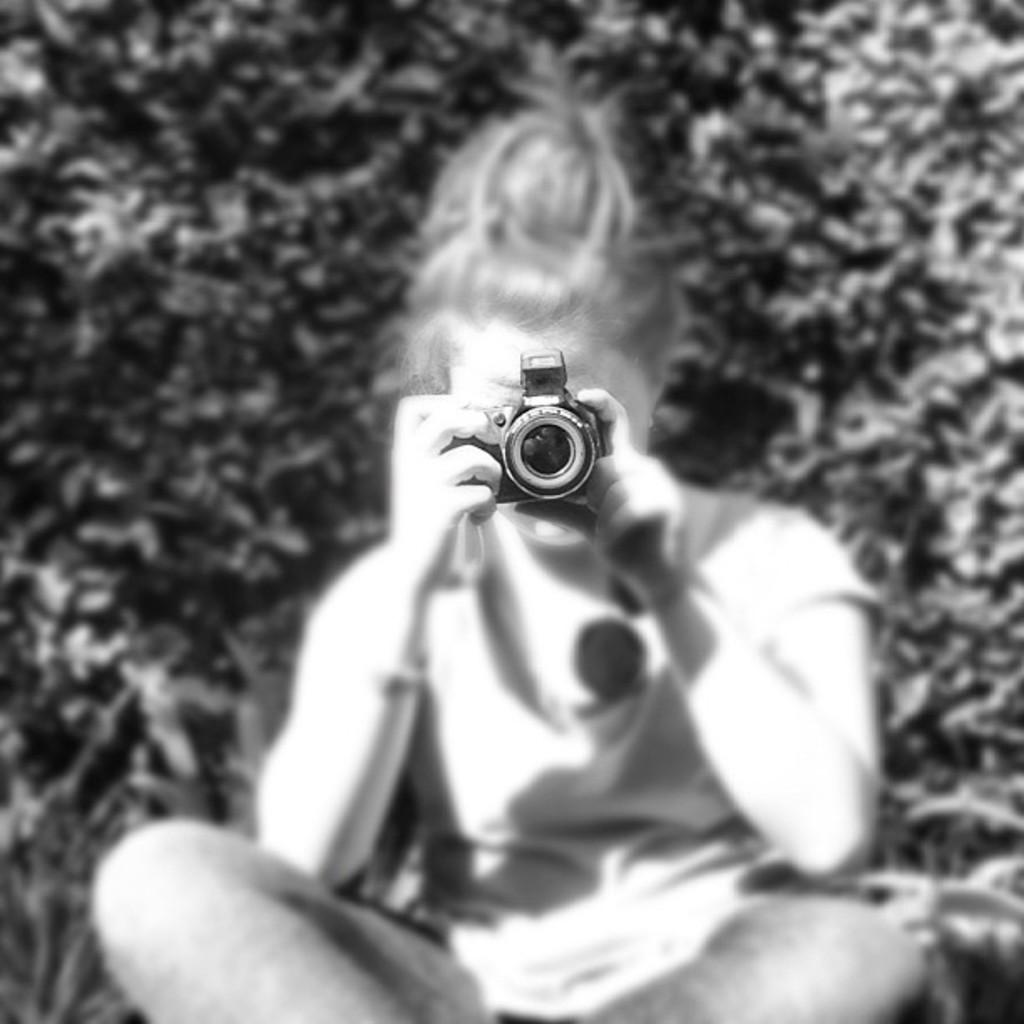What is the color scheme of the image? The image is black and white. What is the main subject of the image? There is a kid in the image. What is the kid doing in the image? The kid is sitting and holding a camera. What is the kid capturing with the camera? The kid is capturing something with the camera. What can be seen in the background of the image? There are trees in the background of the image. What type of jelly can be seen dripping from the kid's nose in the image? There is no jelly or any indication of a nose issue in the image; the kid is holding a camera and appears to be focused on capturing something. 